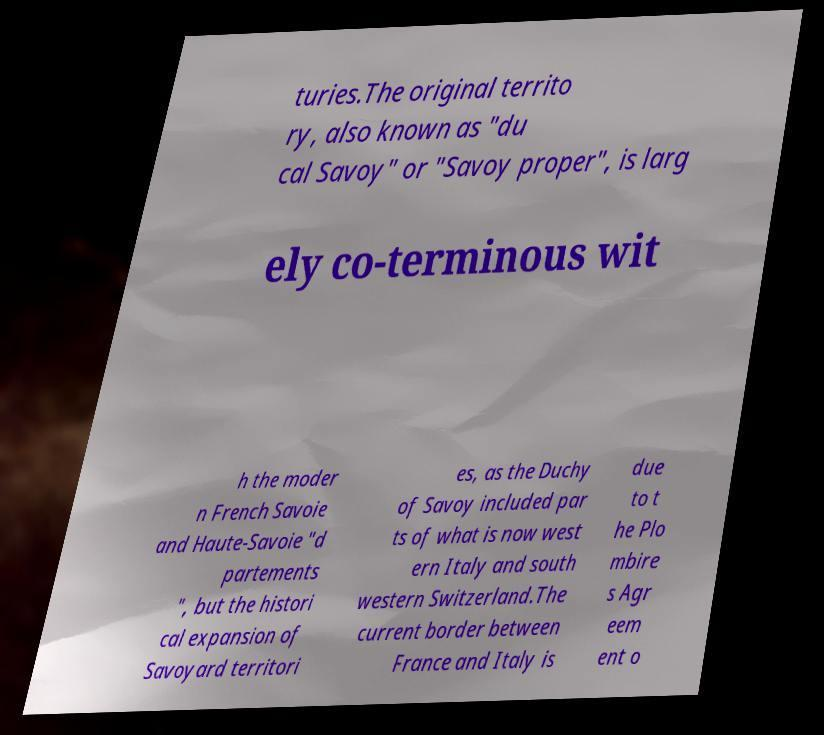There's text embedded in this image that I need extracted. Can you transcribe it verbatim? turies.The original territo ry, also known as "du cal Savoy" or "Savoy proper", is larg ely co-terminous wit h the moder n French Savoie and Haute-Savoie "d partements ", but the histori cal expansion of Savoyard territori es, as the Duchy of Savoy included par ts of what is now west ern Italy and south western Switzerland.The current border between France and Italy is due to t he Plo mbire s Agr eem ent o 